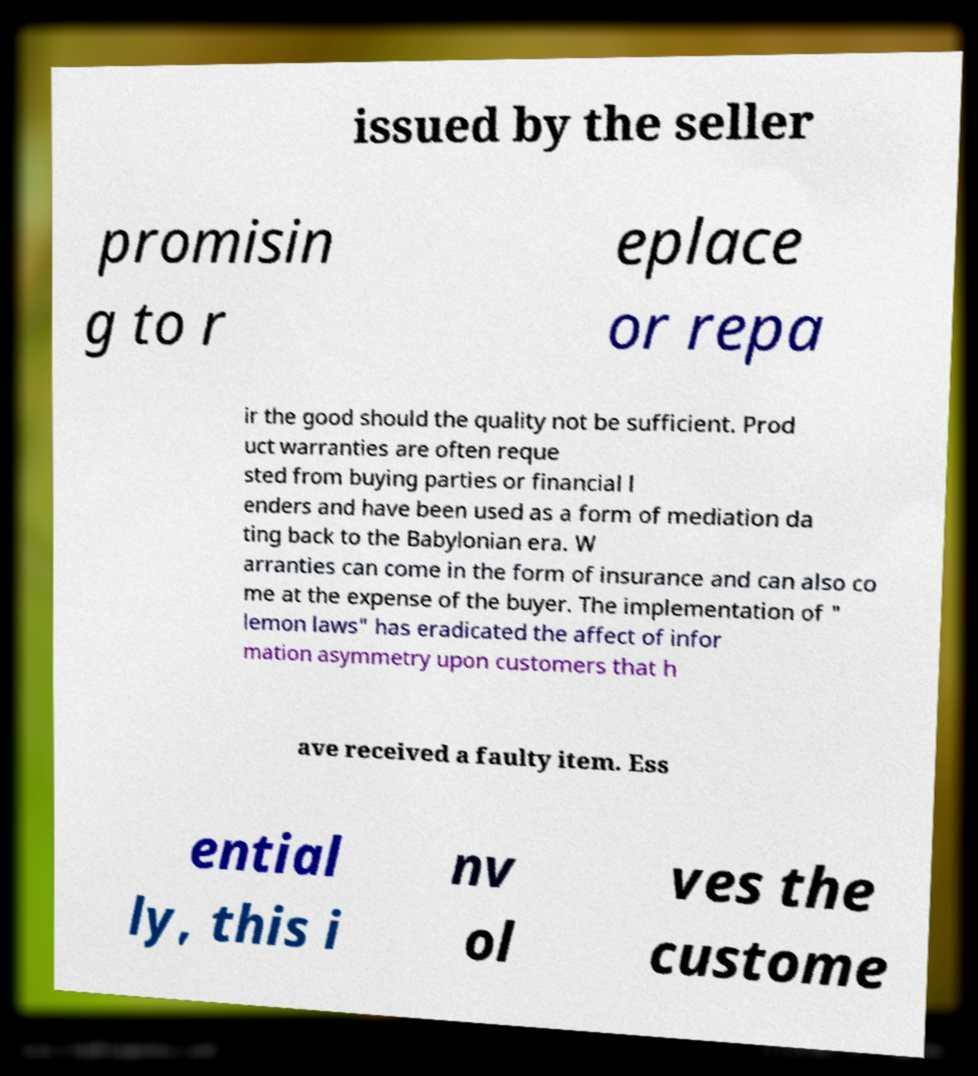Could you assist in decoding the text presented in this image and type it out clearly? issued by the seller promisin g to r eplace or repa ir the good should the quality not be sufficient. Prod uct warranties are often reque sted from buying parties or financial l enders and have been used as a form of mediation da ting back to the Babylonian era. W arranties can come in the form of insurance and can also co me at the expense of the buyer. The implementation of " lemon laws" has eradicated the affect of infor mation asymmetry upon customers that h ave received a faulty item. Ess ential ly, this i nv ol ves the custome 